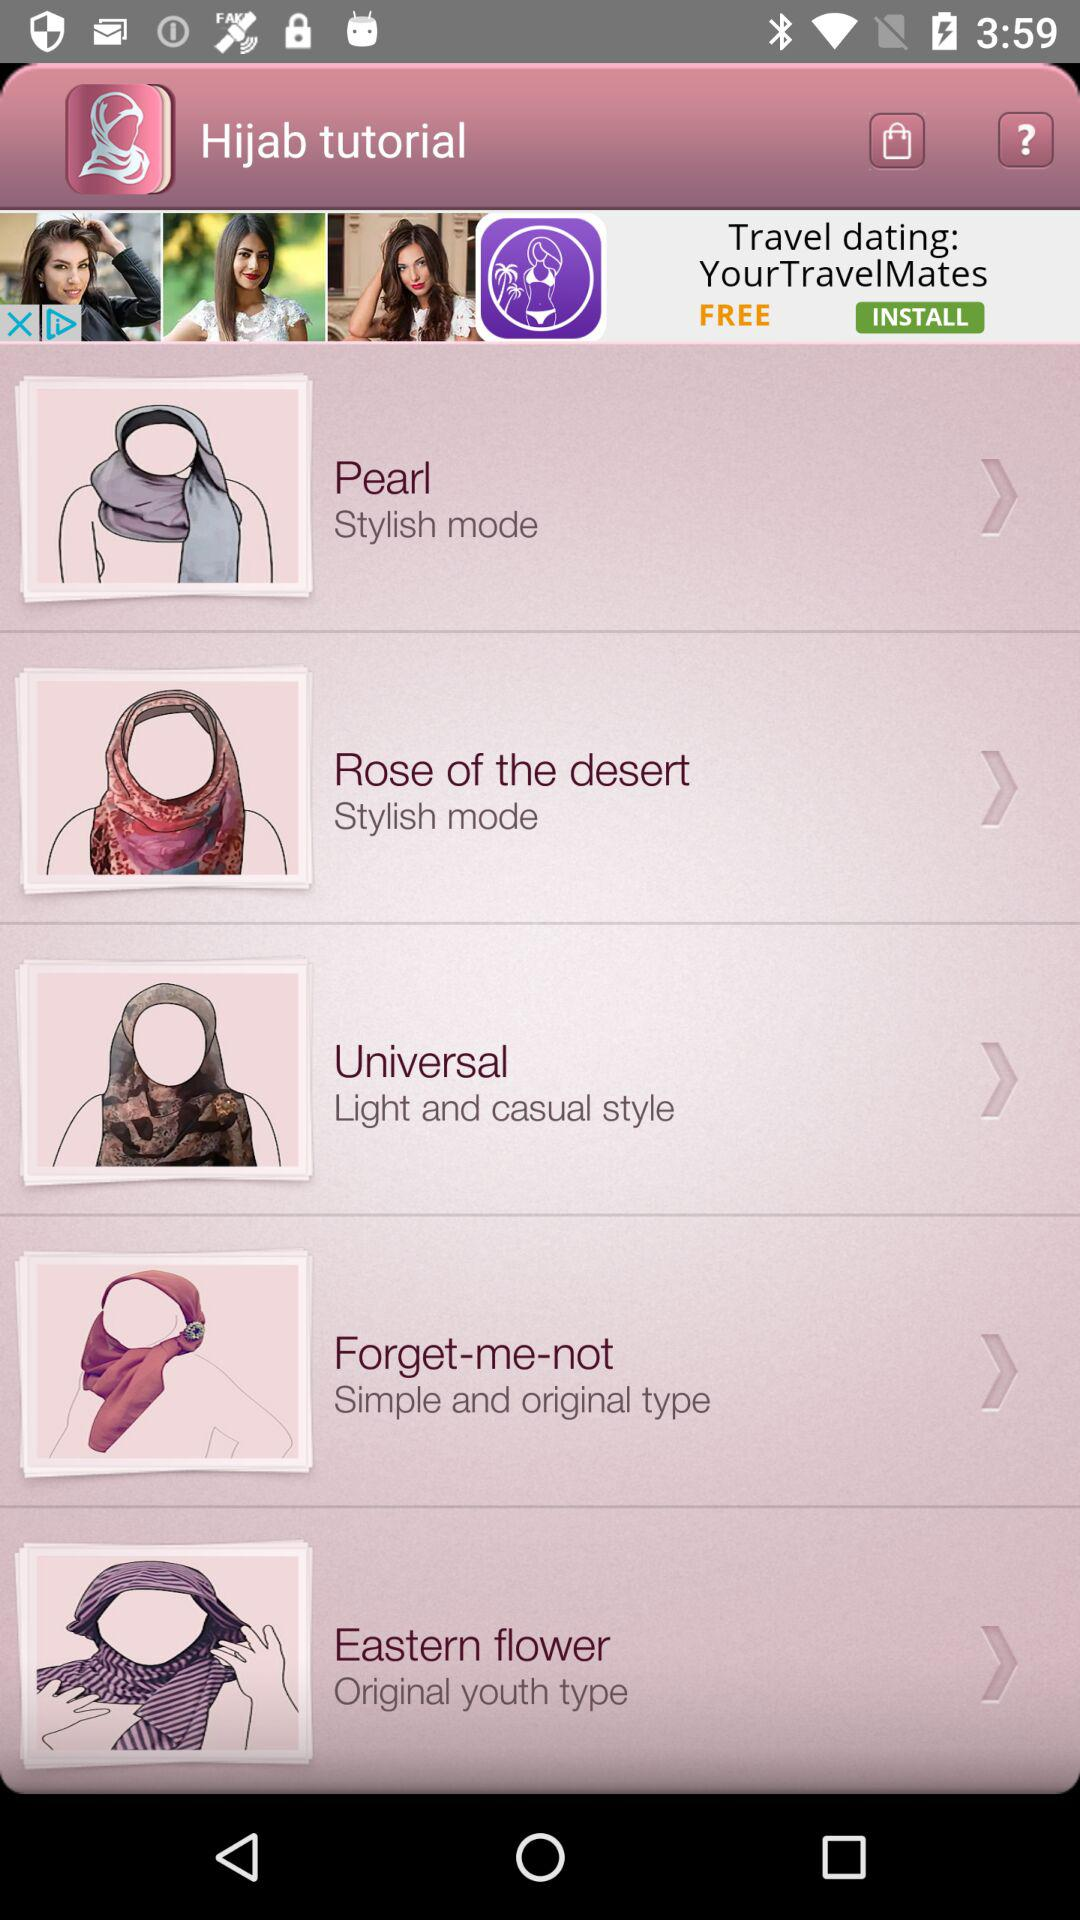What is the type of "Universal" hijab? The "Universal" hijab is "Light and casual style". 